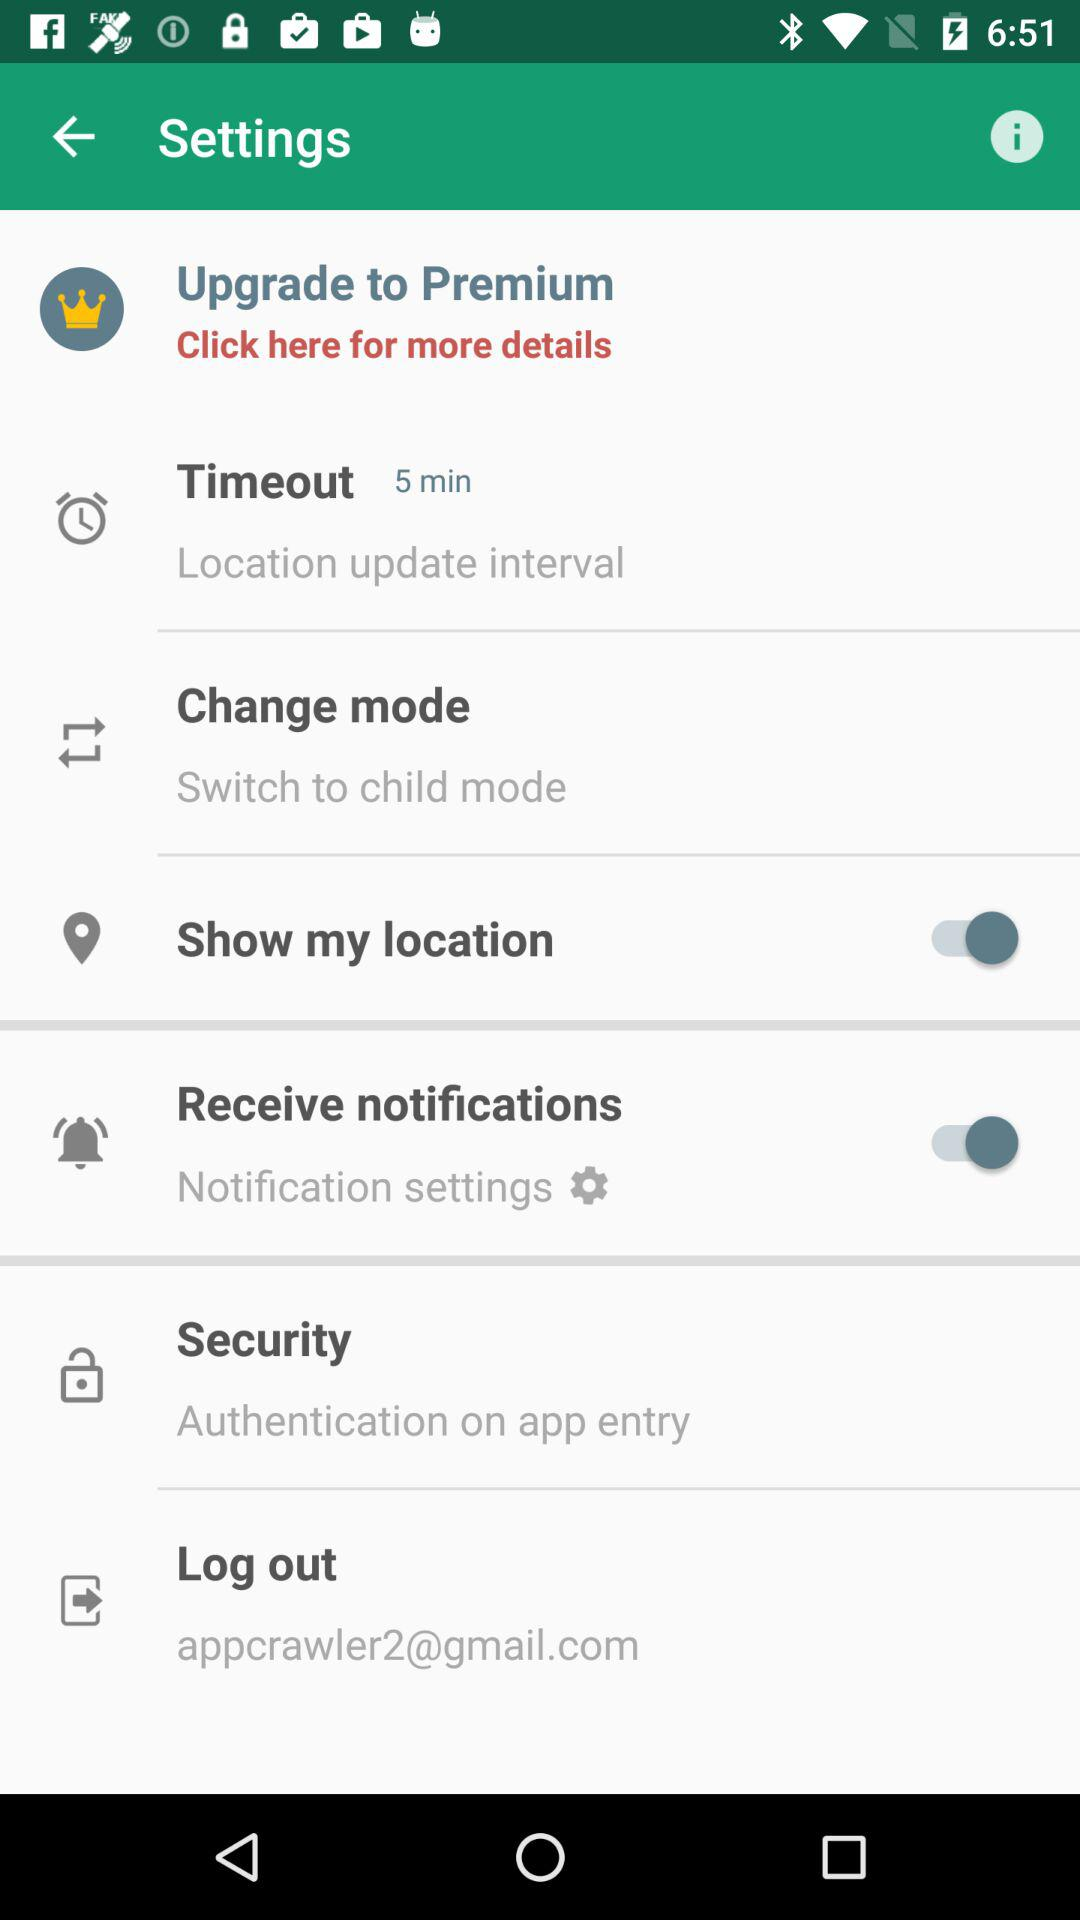What is the status of "Show my location"? The status is "on". 